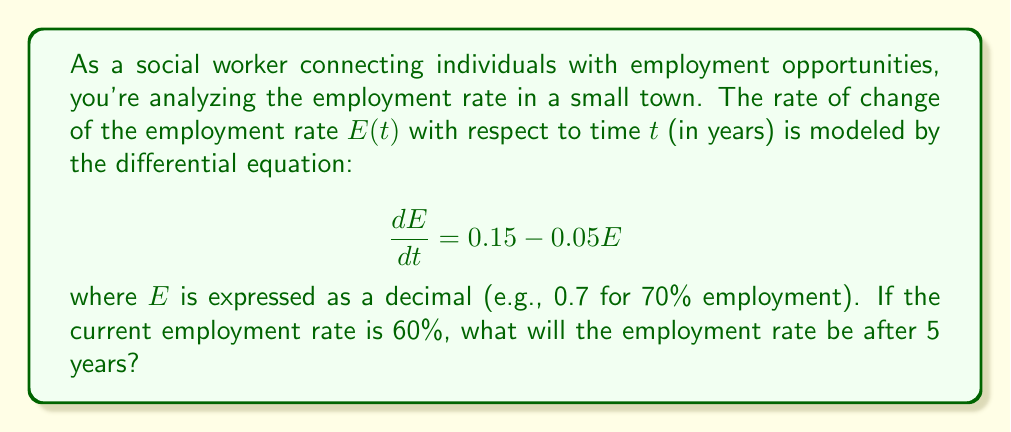Help me with this question. To solve this problem, we need to follow these steps:

1) First, we recognize this as a first-order linear differential equation in the form:

   $$\frac{dE}{dt} + 0.05E = 0.15$$

2) The general solution for this type of equation is:

   $$E(t) = ce^{-0.05t} + 3$$

   where $c$ is a constant we need to determine using the initial condition.

3) We're given that the current employment rate is 60%, or 0.6. This is our initial condition:

   $$E(0) = 0.6$$

4) Using this initial condition, we can find $c$:

   $$0.6 = ce^{-0.05(0)} + 3$$
   $$0.6 = c + 3$$
   $$c = -2.4$$

5) Now we have our particular solution:

   $$E(t) = -2.4e^{-0.05t} + 3$$

6) To find the employment rate after 5 years, we evaluate $E(5)$:

   $$E(5) = -2.4e^{-0.05(5)} + 3$$
   $$E(5) = -2.4e^{-0.25} + 3$$
   $$E(5) = -2.4(0.7788) + 3$$
   $$E(5) = -1.8691 + 3$$
   $$E(5) = 1.1309$$

7) Converting this decimal to a percentage:

   $$1.1309 * 100\% = 113.09\%$$

However, since employment rate cannot exceed 100%, we interpret this result as the employment rate approaching 100% after 5 years.
Answer: After 5 years, the employment rate will approach 100%. 